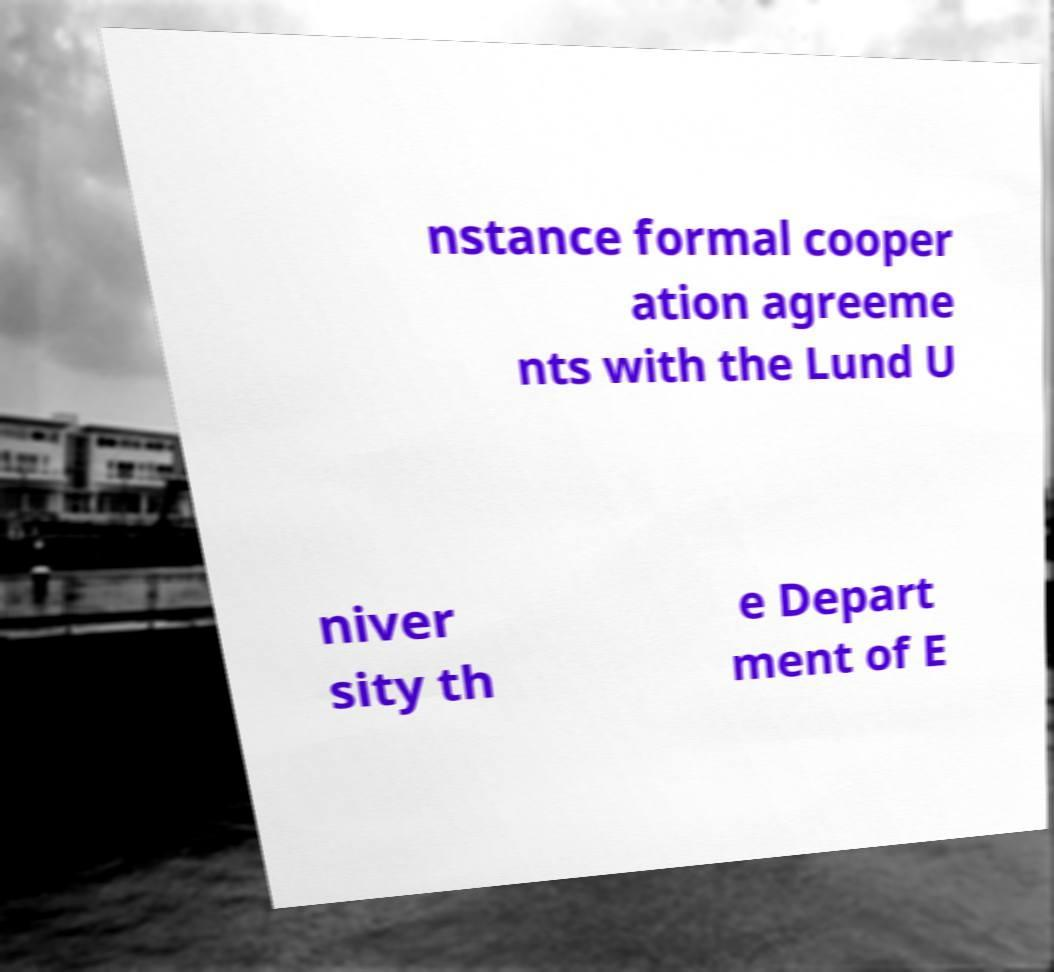For documentation purposes, I need the text within this image transcribed. Could you provide that? nstance formal cooper ation agreeme nts with the Lund U niver sity th e Depart ment of E 